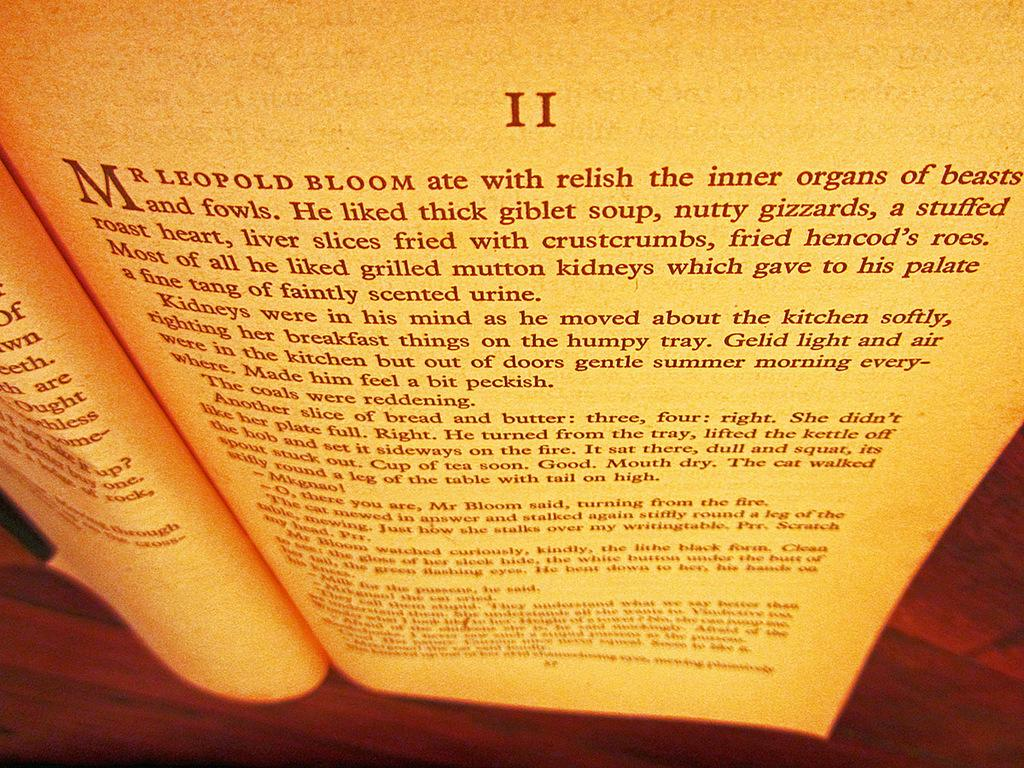<image>
Give a short and clear explanation of the subsequent image. A book open to the first page of chapter 2 that talks about how much Leopold Bloom enjoyed eating animals internal organs. 